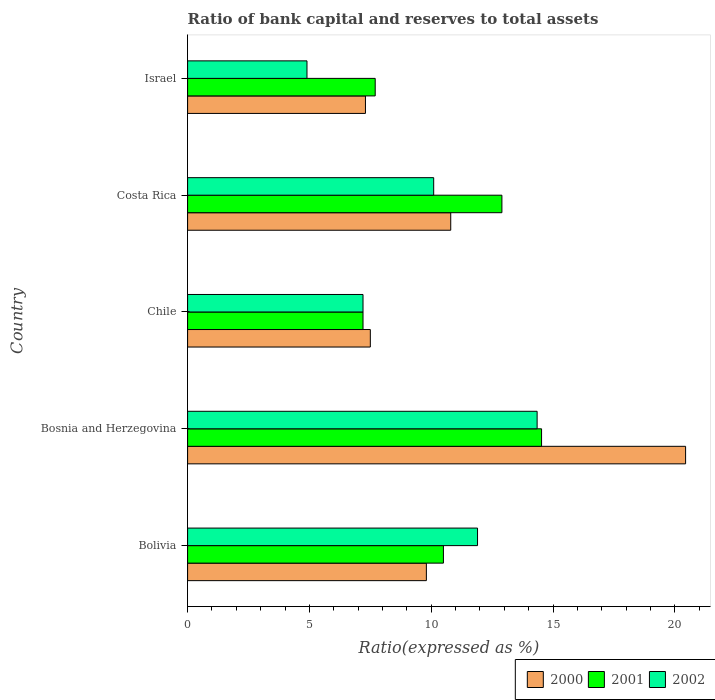Are the number of bars on each tick of the Y-axis equal?
Your answer should be very brief. Yes. What is the label of the 1st group of bars from the top?
Provide a short and direct response. Israel. Across all countries, what is the maximum ratio of bank capital and reserves to total assets in 2001?
Your answer should be very brief. 14.53. In which country was the ratio of bank capital and reserves to total assets in 2000 maximum?
Offer a terse response. Bosnia and Herzegovina. In which country was the ratio of bank capital and reserves to total assets in 2002 minimum?
Make the answer very short. Israel. What is the total ratio of bank capital and reserves to total assets in 2000 in the graph?
Provide a succinct answer. 55.84. What is the difference between the ratio of bank capital and reserves to total assets in 2000 in Bosnia and Herzegovina and that in Costa Rica?
Offer a terse response. 9.64. What is the difference between the ratio of bank capital and reserves to total assets in 2002 in Bolivia and the ratio of bank capital and reserves to total assets in 2001 in Chile?
Your response must be concise. 4.7. What is the average ratio of bank capital and reserves to total assets in 2000 per country?
Your answer should be very brief. 11.17. What is the difference between the ratio of bank capital and reserves to total assets in 2001 and ratio of bank capital and reserves to total assets in 2002 in Bosnia and Herzegovina?
Your answer should be compact. 0.18. What is the ratio of the ratio of bank capital and reserves to total assets in 2001 in Bolivia to that in Chile?
Keep it short and to the point. 1.46. What is the difference between the highest and the second highest ratio of bank capital and reserves to total assets in 2001?
Make the answer very short. 1.63. What is the difference between the highest and the lowest ratio of bank capital and reserves to total assets in 2000?
Ensure brevity in your answer.  13.14. In how many countries, is the ratio of bank capital and reserves to total assets in 2000 greater than the average ratio of bank capital and reserves to total assets in 2000 taken over all countries?
Your answer should be very brief. 1. What does the 2nd bar from the bottom in Bolivia represents?
Provide a succinct answer. 2001. Are all the bars in the graph horizontal?
Keep it short and to the point. Yes. Does the graph contain any zero values?
Your response must be concise. No. Does the graph contain grids?
Provide a short and direct response. No. Where does the legend appear in the graph?
Provide a succinct answer. Bottom right. What is the title of the graph?
Make the answer very short. Ratio of bank capital and reserves to total assets. Does "1985" appear as one of the legend labels in the graph?
Provide a succinct answer. No. What is the label or title of the X-axis?
Keep it short and to the point. Ratio(expressed as %). What is the label or title of the Y-axis?
Give a very brief answer. Country. What is the Ratio(expressed as %) in 2002 in Bolivia?
Offer a very short reply. 11.9. What is the Ratio(expressed as %) of 2000 in Bosnia and Herzegovina?
Keep it short and to the point. 20.44. What is the Ratio(expressed as %) of 2001 in Bosnia and Herzegovina?
Offer a very short reply. 14.53. What is the Ratio(expressed as %) of 2002 in Bosnia and Herzegovina?
Your answer should be compact. 14.35. What is the Ratio(expressed as %) in 2000 in Chile?
Offer a terse response. 7.5. What is the Ratio(expressed as %) of 2001 in Chile?
Ensure brevity in your answer.  7.2. What is the Ratio(expressed as %) in 2002 in Israel?
Ensure brevity in your answer.  4.9. Across all countries, what is the maximum Ratio(expressed as %) in 2000?
Provide a short and direct response. 20.44. Across all countries, what is the maximum Ratio(expressed as %) of 2001?
Your answer should be very brief. 14.53. Across all countries, what is the maximum Ratio(expressed as %) in 2002?
Make the answer very short. 14.35. Across all countries, what is the minimum Ratio(expressed as %) of 2002?
Your response must be concise. 4.9. What is the total Ratio(expressed as %) of 2000 in the graph?
Provide a short and direct response. 55.84. What is the total Ratio(expressed as %) in 2001 in the graph?
Give a very brief answer. 52.83. What is the total Ratio(expressed as %) of 2002 in the graph?
Make the answer very short. 48.45. What is the difference between the Ratio(expressed as %) of 2000 in Bolivia and that in Bosnia and Herzegovina?
Your answer should be very brief. -10.64. What is the difference between the Ratio(expressed as %) in 2001 in Bolivia and that in Bosnia and Herzegovina?
Offer a very short reply. -4.03. What is the difference between the Ratio(expressed as %) in 2002 in Bolivia and that in Bosnia and Herzegovina?
Make the answer very short. -2.45. What is the difference between the Ratio(expressed as %) in 2002 in Bolivia and that in Chile?
Provide a succinct answer. 4.7. What is the difference between the Ratio(expressed as %) in 2000 in Bolivia and that in Costa Rica?
Give a very brief answer. -1. What is the difference between the Ratio(expressed as %) in 2001 in Bolivia and that in Costa Rica?
Provide a succinct answer. -2.4. What is the difference between the Ratio(expressed as %) of 2000 in Bolivia and that in Israel?
Provide a succinct answer. 2.5. What is the difference between the Ratio(expressed as %) in 2001 in Bolivia and that in Israel?
Offer a terse response. 2.8. What is the difference between the Ratio(expressed as %) of 2000 in Bosnia and Herzegovina and that in Chile?
Give a very brief answer. 12.94. What is the difference between the Ratio(expressed as %) of 2001 in Bosnia and Herzegovina and that in Chile?
Your response must be concise. 7.33. What is the difference between the Ratio(expressed as %) of 2002 in Bosnia and Herzegovina and that in Chile?
Make the answer very short. 7.15. What is the difference between the Ratio(expressed as %) in 2000 in Bosnia and Herzegovina and that in Costa Rica?
Keep it short and to the point. 9.64. What is the difference between the Ratio(expressed as %) in 2001 in Bosnia and Herzegovina and that in Costa Rica?
Your response must be concise. 1.63. What is the difference between the Ratio(expressed as %) in 2002 in Bosnia and Herzegovina and that in Costa Rica?
Give a very brief answer. 4.25. What is the difference between the Ratio(expressed as %) in 2000 in Bosnia and Herzegovina and that in Israel?
Ensure brevity in your answer.  13.14. What is the difference between the Ratio(expressed as %) in 2001 in Bosnia and Herzegovina and that in Israel?
Your answer should be compact. 6.83. What is the difference between the Ratio(expressed as %) of 2002 in Bosnia and Herzegovina and that in Israel?
Your answer should be very brief. 9.45. What is the difference between the Ratio(expressed as %) in 2000 in Chile and that in Costa Rica?
Your response must be concise. -3.3. What is the difference between the Ratio(expressed as %) in 2002 in Chile and that in Costa Rica?
Provide a succinct answer. -2.9. What is the difference between the Ratio(expressed as %) in 2001 in Costa Rica and that in Israel?
Your answer should be very brief. 5.2. What is the difference between the Ratio(expressed as %) of 2002 in Costa Rica and that in Israel?
Your answer should be very brief. 5.2. What is the difference between the Ratio(expressed as %) of 2000 in Bolivia and the Ratio(expressed as %) of 2001 in Bosnia and Herzegovina?
Provide a short and direct response. -4.73. What is the difference between the Ratio(expressed as %) in 2000 in Bolivia and the Ratio(expressed as %) in 2002 in Bosnia and Herzegovina?
Your answer should be compact. -4.55. What is the difference between the Ratio(expressed as %) of 2001 in Bolivia and the Ratio(expressed as %) of 2002 in Bosnia and Herzegovina?
Make the answer very short. -3.85. What is the difference between the Ratio(expressed as %) in 2000 in Bolivia and the Ratio(expressed as %) in 2001 in Chile?
Offer a very short reply. 2.6. What is the difference between the Ratio(expressed as %) of 2000 in Bolivia and the Ratio(expressed as %) of 2002 in Chile?
Offer a terse response. 2.6. What is the difference between the Ratio(expressed as %) of 2001 in Bolivia and the Ratio(expressed as %) of 2002 in Chile?
Make the answer very short. 3.3. What is the difference between the Ratio(expressed as %) in 2000 in Bolivia and the Ratio(expressed as %) in 2001 in Costa Rica?
Offer a very short reply. -3.1. What is the difference between the Ratio(expressed as %) of 2000 in Bosnia and Herzegovina and the Ratio(expressed as %) of 2001 in Chile?
Make the answer very short. 13.24. What is the difference between the Ratio(expressed as %) of 2000 in Bosnia and Herzegovina and the Ratio(expressed as %) of 2002 in Chile?
Offer a very short reply. 13.24. What is the difference between the Ratio(expressed as %) of 2001 in Bosnia and Herzegovina and the Ratio(expressed as %) of 2002 in Chile?
Keep it short and to the point. 7.33. What is the difference between the Ratio(expressed as %) in 2000 in Bosnia and Herzegovina and the Ratio(expressed as %) in 2001 in Costa Rica?
Your answer should be compact. 7.54. What is the difference between the Ratio(expressed as %) of 2000 in Bosnia and Herzegovina and the Ratio(expressed as %) of 2002 in Costa Rica?
Provide a short and direct response. 10.34. What is the difference between the Ratio(expressed as %) in 2001 in Bosnia and Herzegovina and the Ratio(expressed as %) in 2002 in Costa Rica?
Give a very brief answer. 4.43. What is the difference between the Ratio(expressed as %) in 2000 in Bosnia and Herzegovina and the Ratio(expressed as %) in 2001 in Israel?
Keep it short and to the point. 12.74. What is the difference between the Ratio(expressed as %) in 2000 in Bosnia and Herzegovina and the Ratio(expressed as %) in 2002 in Israel?
Make the answer very short. 15.54. What is the difference between the Ratio(expressed as %) in 2001 in Bosnia and Herzegovina and the Ratio(expressed as %) in 2002 in Israel?
Offer a very short reply. 9.63. What is the difference between the Ratio(expressed as %) in 2000 in Chile and the Ratio(expressed as %) in 2002 in Costa Rica?
Keep it short and to the point. -2.6. What is the difference between the Ratio(expressed as %) in 2000 in Chile and the Ratio(expressed as %) in 2001 in Israel?
Offer a terse response. -0.2. What is the difference between the Ratio(expressed as %) in 2001 in Chile and the Ratio(expressed as %) in 2002 in Israel?
Provide a succinct answer. 2.3. What is the difference between the Ratio(expressed as %) of 2000 in Costa Rica and the Ratio(expressed as %) of 2001 in Israel?
Make the answer very short. 3.1. What is the average Ratio(expressed as %) of 2000 per country?
Make the answer very short. 11.17. What is the average Ratio(expressed as %) in 2001 per country?
Keep it short and to the point. 10.57. What is the average Ratio(expressed as %) of 2002 per country?
Your answer should be very brief. 9.69. What is the difference between the Ratio(expressed as %) of 2000 and Ratio(expressed as %) of 2001 in Bosnia and Herzegovina?
Your response must be concise. 5.91. What is the difference between the Ratio(expressed as %) in 2000 and Ratio(expressed as %) in 2002 in Bosnia and Herzegovina?
Your answer should be compact. 6.09. What is the difference between the Ratio(expressed as %) in 2001 and Ratio(expressed as %) in 2002 in Bosnia and Herzegovina?
Provide a succinct answer. 0.18. What is the difference between the Ratio(expressed as %) in 2000 and Ratio(expressed as %) in 2001 in Chile?
Make the answer very short. 0.3. What is the difference between the Ratio(expressed as %) in 2000 and Ratio(expressed as %) in 2002 in Chile?
Provide a succinct answer. 0.3. What is the difference between the Ratio(expressed as %) in 2001 and Ratio(expressed as %) in 2002 in Costa Rica?
Your answer should be compact. 2.8. What is the difference between the Ratio(expressed as %) of 2000 and Ratio(expressed as %) of 2002 in Israel?
Offer a terse response. 2.4. What is the difference between the Ratio(expressed as %) of 2001 and Ratio(expressed as %) of 2002 in Israel?
Ensure brevity in your answer.  2.8. What is the ratio of the Ratio(expressed as %) of 2000 in Bolivia to that in Bosnia and Herzegovina?
Your answer should be very brief. 0.48. What is the ratio of the Ratio(expressed as %) in 2001 in Bolivia to that in Bosnia and Herzegovina?
Give a very brief answer. 0.72. What is the ratio of the Ratio(expressed as %) of 2002 in Bolivia to that in Bosnia and Herzegovina?
Your answer should be very brief. 0.83. What is the ratio of the Ratio(expressed as %) in 2000 in Bolivia to that in Chile?
Make the answer very short. 1.31. What is the ratio of the Ratio(expressed as %) in 2001 in Bolivia to that in Chile?
Offer a very short reply. 1.46. What is the ratio of the Ratio(expressed as %) in 2002 in Bolivia to that in Chile?
Provide a succinct answer. 1.65. What is the ratio of the Ratio(expressed as %) of 2000 in Bolivia to that in Costa Rica?
Make the answer very short. 0.91. What is the ratio of the Ratio(expressed as %) of 2001 in Bolivia to that in Costa Rica?
Provide a short and direct response. 0.81. What is the ratio of the Ratio(expressed as %) of 2002 in Bolivia to that in Costa Rica?
Make the answer very short. 1.18. What is the ratio of the Ratio(expressed as %) in 2000 in Bolivia to that in Israel?
Make the answer very short. 1.34. What is the ratio of the Ratio(expressed as %) of 2001 in Bolivia to that in Israel?
Your answer should be very brief. 1.36. What is the ratio of the Ratio(expressed as %) of 2002 in Bolivia to that in Israel?
Make the answer very short. 2.43. What is the ratio of the Ratio(expressed as %) in 2000 in Bosnia and Herzegovina to that in Chile?
Offer a terse response. 2.73. What is the ratio of the Ratio(expressed as %) in 2001 in Bosnia and Herzegovina to that in Chile?
Keep it short and to the point. 2.02. What is the ratio of the Ratio(expressed as %) in 2002 in Bosnia and Herzegovina to that in Chile?
Make the answer very short. 1.99. What is the ratio of the Ratio(expressed as %) of 2000 in Bosnia and Herzegovina to that in Costa Rica?
Ensure brevity in your answer.  1.89. What is the ratio of the Ratio(expressed as %) in 2001 in Bosnia and Herzegovina to that in Costa Rica?
Your answer should be compact. 1.13. What is the ratio of the Ratio(expressed as %) of 2002 in Bosnia and Herzegovina to that in Costa Rica?
Give a very brief answer. 1.42. What is the ratio of the Ratio(expressed as %) of 2000 in Bosnia and Herzegovina to that in Israel?
Your response must be concise. 2.8. What is the ratio of the Ratio(expressed as %) in 2001 in Bosnia and Herzegovina to that in Israel?
Keep it short and to the point. 1.89. What is the ratio of the Ratio(expressed as %) of 2002 in Bosnia and Herzegovina to that in Israel?
Offer a very short reply. 2.93. What is the ratio of the Ratio(expressed as %) in 2000 in Chile to that in Costa Rica?
Your answer should be compact. 0.69. What is the ratio of the Ratio(expressed as %) in 2001 in Chile to that in Costa Rica?
Your answer should be compact. 0.56. What is the ratio of the Ratio(expressed as %) of 2002 in Chile to that in Costa Rica?
Provide a succinct answer. 0.71. What is the ratio of the Ratio(expressed as %) of 2000 in Chile to that in Israel?
Make the answer very short. 1.03. What is the ratio of the Ratio(expressed as %) in 2001 in Chile to that in Israel?
Your answer should be very brief. 0.94. What is the ratio of the Ratio(expressed as %) of 2002 in Chile to that in Israel?
Your response must be concise. 1.47. What is the ratio of the Ratio(expressed as %) in 2000 in Costa Rica to that in Israel?
Provide a succinct answer. 1.48. What is the ratio of the Ratio(expressed as %) of 2001 in Costa Rica to that in Israel?
Offer a terse response. 1.68. What is the ratio of the Ratio(expressed as %) in 2002 in Costa Rica to that in Israel?
Offer a terse response. 2.06. What is the difference between the highest and the second highest Ratio(expressed as %) in 2000?
Offer a terse response. 9.64. What is the difference between the highest and the second highest Ratio(expressed as %) in 2001?
Offer a terse response. 1.63. What is the difference between the highest and the second highest Ratio(expressed as %) of 2002?
Provide a succinct answer. 2.45. What is the difference between the highest and the lowest Ratio(expressed as %) in 2000?
Provide a short and direct response. 13.14. What is the difference between the highest and the lowest Ratio(expressed as %) of 2001?
Your answer should be compact. 7.33. What is the difference between the highest and the lowest Ratio(expressed as %) of 2002?
Your response must be concise. 9.45. 